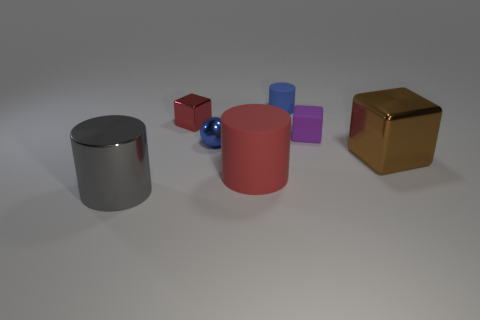What mood does the arrangement of these objects convey? The arrangement of these objects provides a balanced yet static composition. The neutral background and soft lighting create a calm and introspective mood, inviting the viewer to focus on the shapes, colors, and materials of the objects without distraction. 